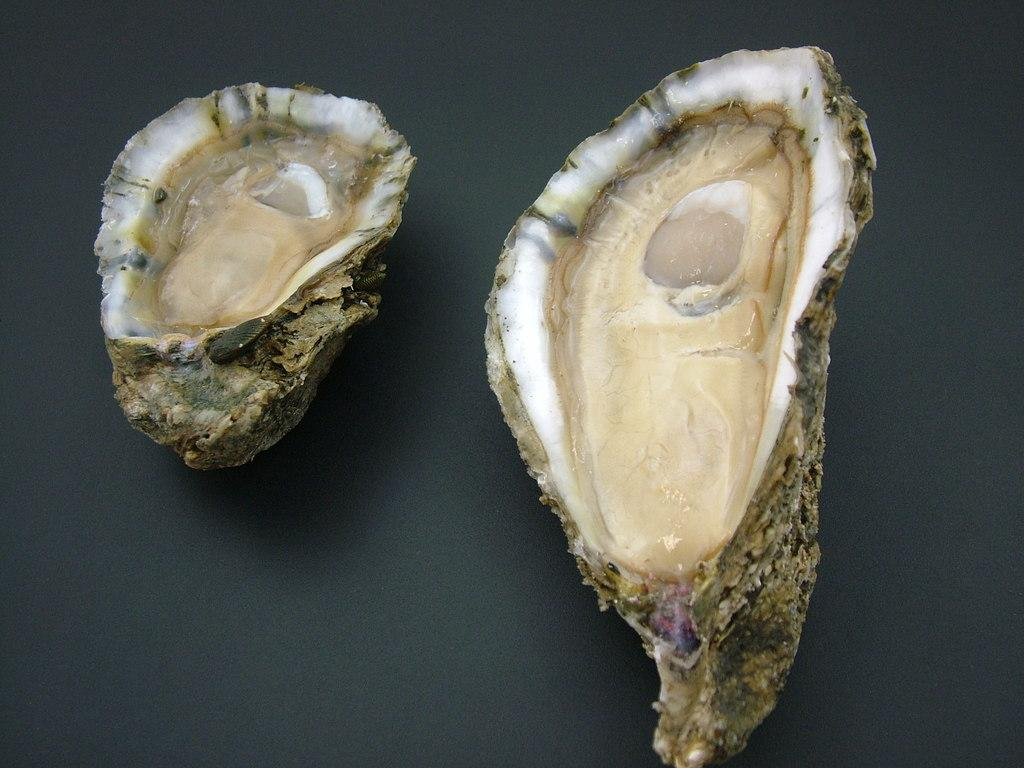What type of seafood can be seen in the image? There are oysters present in the image. How many sisters are depicted in the image? There are no sisters present in the image; it features oysters. What type of vegetable can be seen growing in the image? There is no vegetable present in the image; it features oysters. 